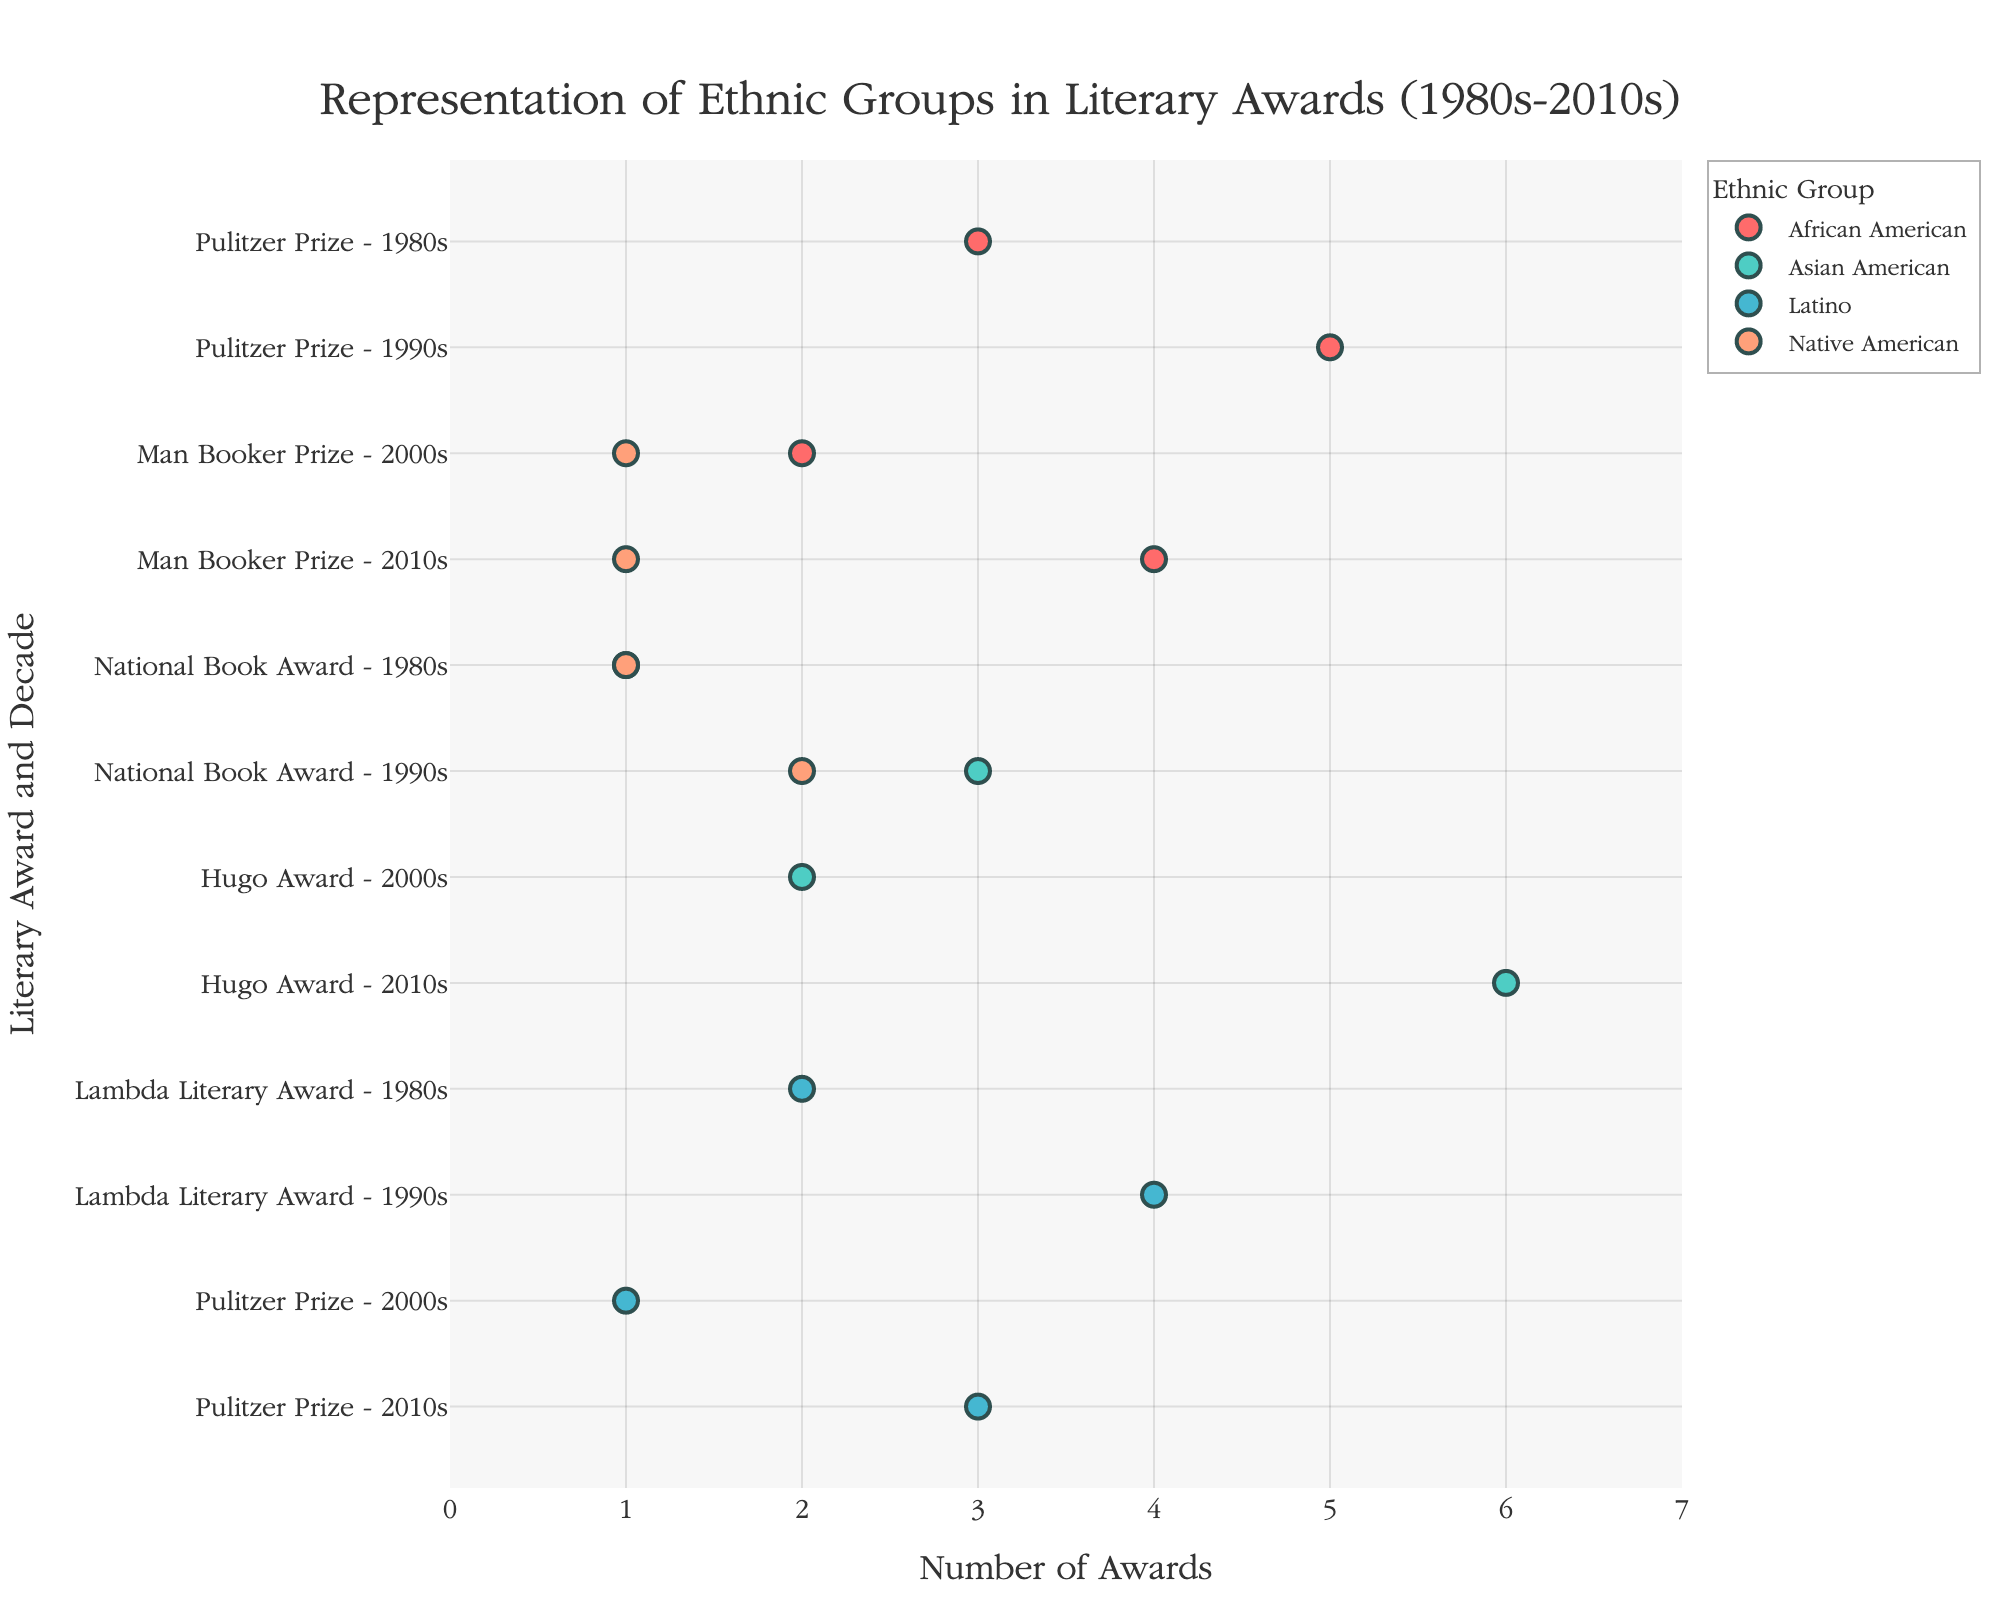How many literary awards did African American writers win in the 2010s? Look for the African American group in the 2010s decade, then sum up the awards for each literary award listed: 4 (Man Booker Prize).
Answer: 4 Which ethnic group received the highest number of awards in the 2010s? Compare the number of awards for each ethnic group in the 2010s. Asian American has 6 (Hugo Award), which is higher than any other group.
Answer: Asian American What is the total number of awards won by Latino writers across all decades? Sum the awards won by Latino writers for all decades: 2 (Lambda Literary Award, 1980s) + 4 (Lambda Literary Award, 1990s) + 1 (Pulitzer Prize, 2000s) + 3 (Pulitzer Prize, 2010s) = 10.
Answer: 10 How many more awards did Asian American writers win in the 2010s compared to the 2000s? Subtract the number of awards won by Asian American writers in the 2000s from those in the 2010s: 6 (2010s) - 2 (2000s) = 4.
Answer: 4 Which decade saw the highest number of awards for Native American writers? Compare the number of awards for Native American writers across different decades: 1 (1980s), 2 (1990s), 1 (2000s), 1 (2010s). The 1990s had the highest, with 2 awards.
Answer: 1990s Do Latino writers receive more awards in the Pulitzer Prize or the Lambda Literary Award? Compare the total number of awards received by Latino writers in both categories: 4 (2 in the 1980s and 2 in the 1990s for Lambda Literary Award), 4 (1 in the 2000s and 3 in the 2010s for Pulitzer Prize). They received the same number (4 each).
Answer: Neither, they are equal How many awards in total were received by all ethnic groups in the 1990s? Sum the awards for each ethnic group in the 1990s: 5 (African American) + 3 (Asian American) + 2 (Native American) + 4 (Latino) = 14.
Answer: 14 